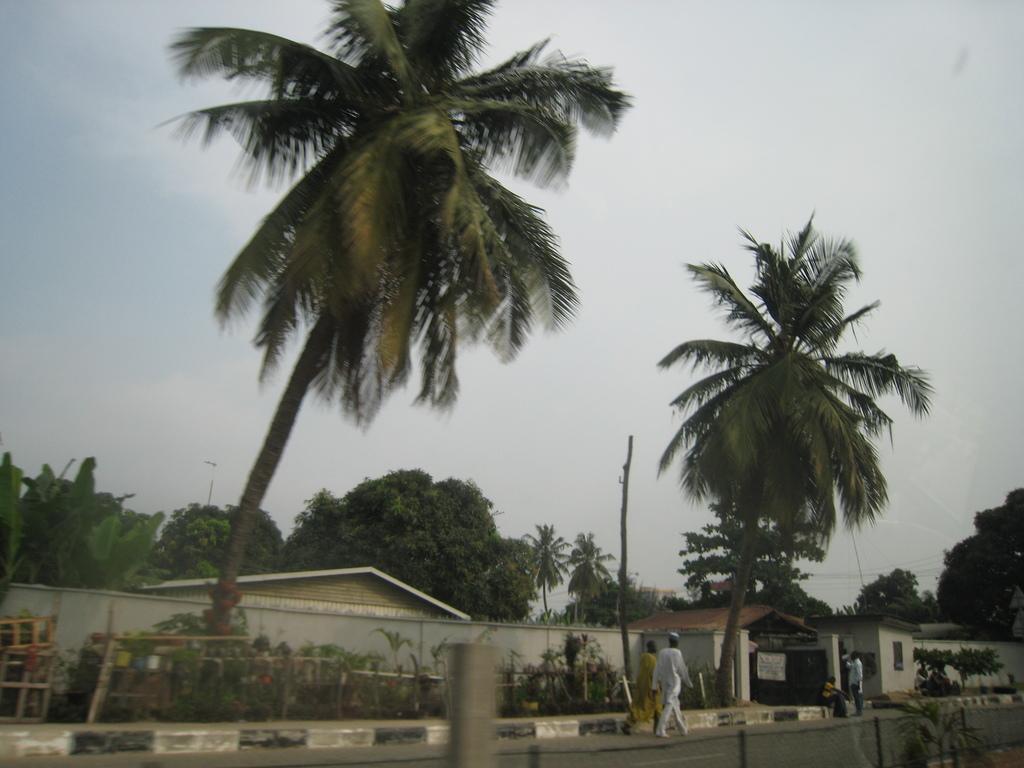Describe this image in one or two sentences. In this image I can see two persons walking, few trees and plants in green color and the sky is in white color and I can also see the house. 